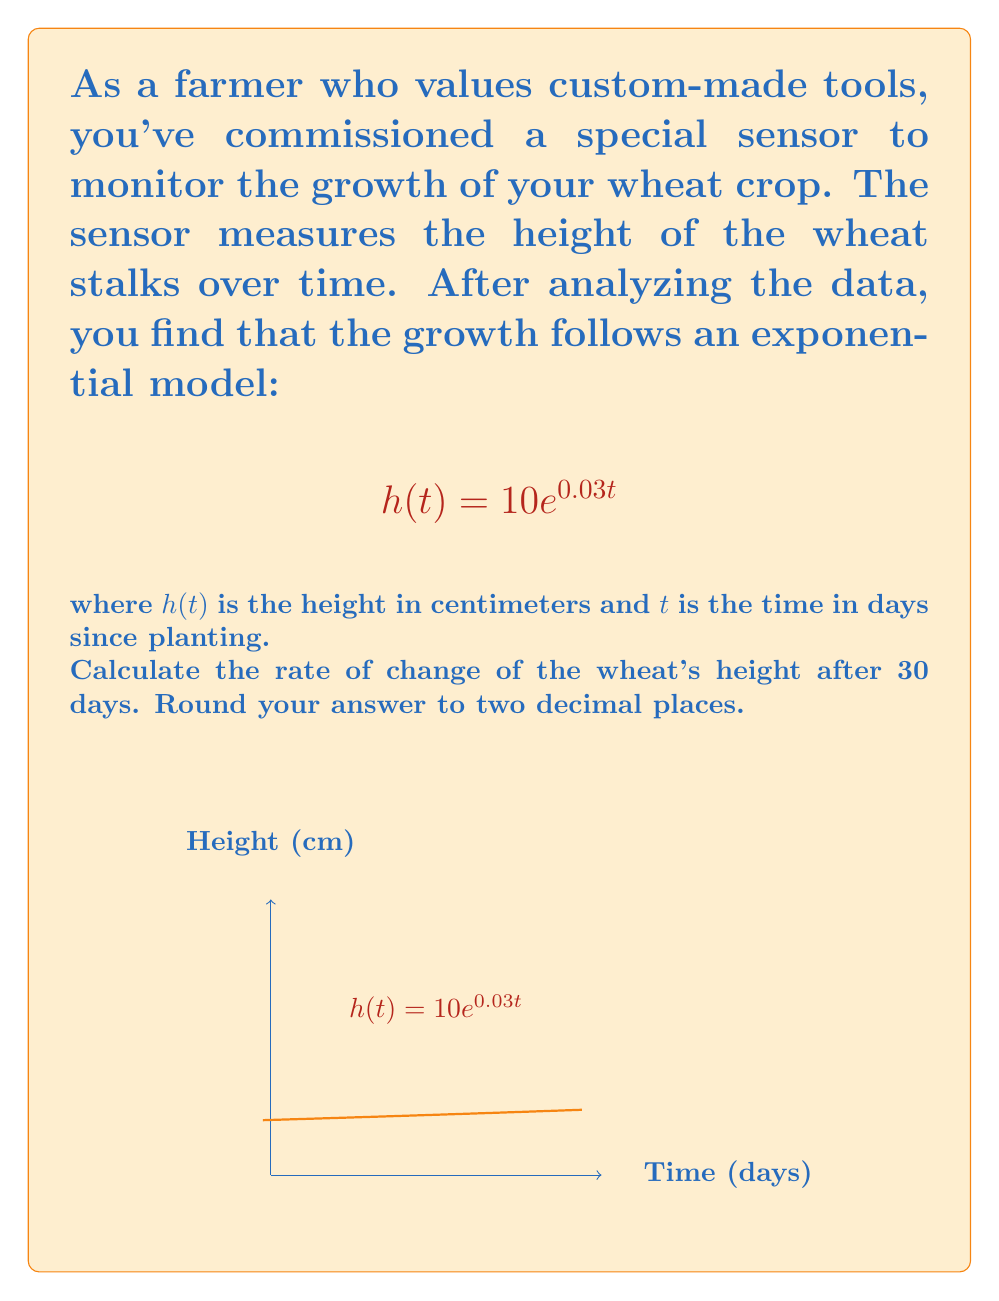What is the answer to this math problem? To find the rate of change of the wheat's height, we need to differentiate the given function $h(t)$ with respect to time $t$ and then evaluate it at $t=30$.

Step 1: Differentiate $h(t)$ with respect to $t$
$$\frac{d}{dt}h(t) = \frac{d}{dt}(10e^{0.03t})$$
Using the chain rule:
$$\frac{d}{dt}h(t) = 10 \cdot 0.03 \cdot e^{0.03t}$$
$$\frac{d}{dt}h(t) = 0.3e^{0.03t}$$

Step 2: Evaluate the derivative at $t=30$
$$\frac{d}{dt}h(30) = 0.3e^{0.03(30)}$$
$$\frac{d}{dt}h(30) = 0.3e^{0.9}$$

Step 3: Calculate the value
$$\frac{d}{dt}h(30) = 0.3 \cdot 2.4596 = 0.73788$$

Step 4: Round to two decimal places
$$\frac{d}{dt}h(30) \approx 0.74$$

Therefore, the rate of change of the wheat's height after 30 days is approximately 0.74 cm/day.
Answer: 0.74 cm/day 